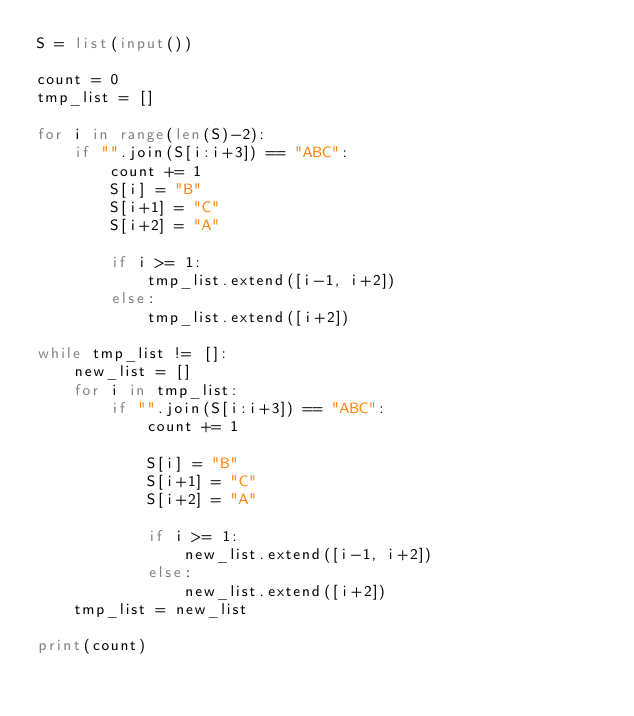Convert code to text. <code><loc_0><loc_0><loc_500><loc_500><_Python_>S = list(input())

count = 0
tmp_list = []

for i in range(len(S)-2):
    if "".join(S[i:i+3]) == "ABC":
        count += 1        
        S[i] = "B"
        S[i+1] = "C"
        S[i+2] = "A"        
        
        if i >= 1:
            tmp_list.extend([i-1, i+2])
        else:
            tmp_list.extend([i+2])
                        
while tmp_list != []:
    new_list = []
    for i in tmp_list:
        if "".join(S[i:i+3]) == "ABC":
            count += 1
            
            S[i] = "B"
            S[i+1] = "C"
            S[i+2] = "A"
            
            if i >= 1:
                new_list.extend([i-1, i+2])
            else:
                new_list.extend([i+2])
    tmp_list = new_list

print(count)</code> 